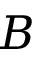Convert formula to latex. <formula><loc_0><loc_0><loc_500><loc_500>B</formula> 